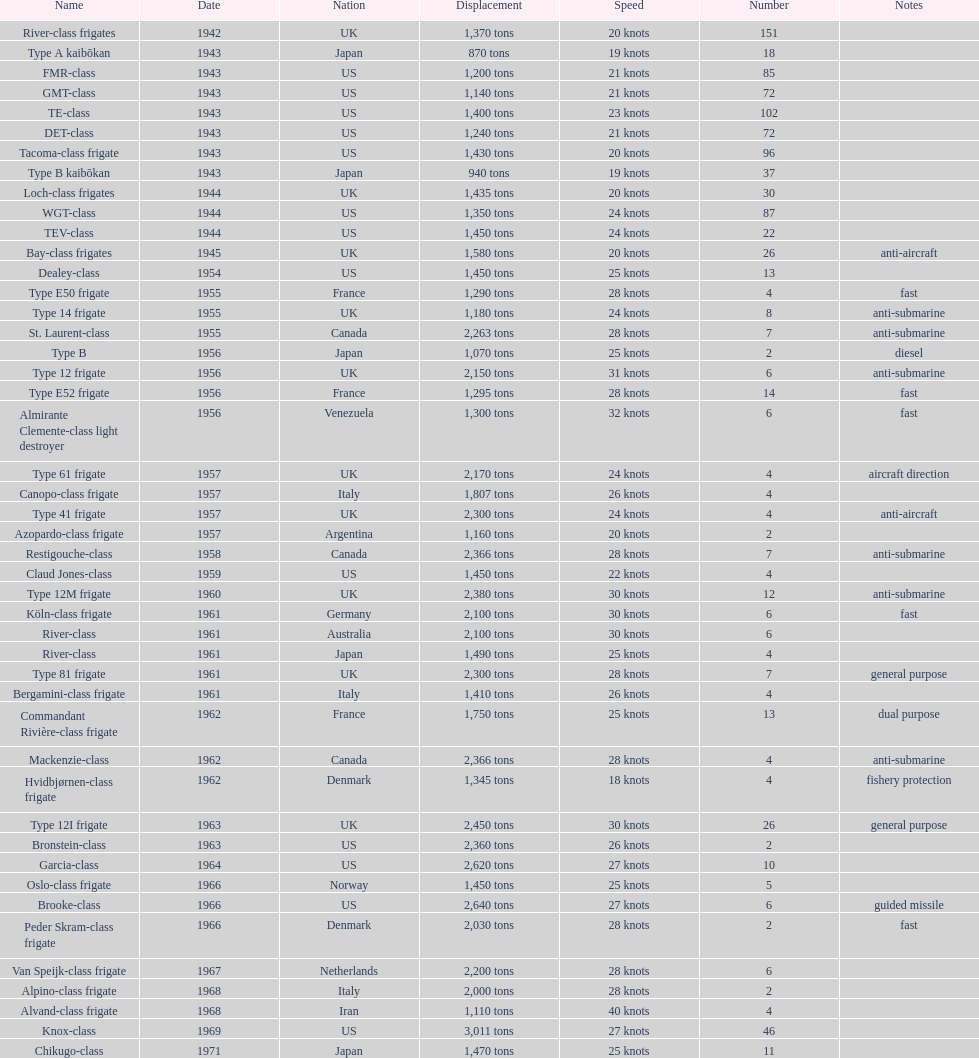Which name corresponds to the largest displacement? Knox-class. 